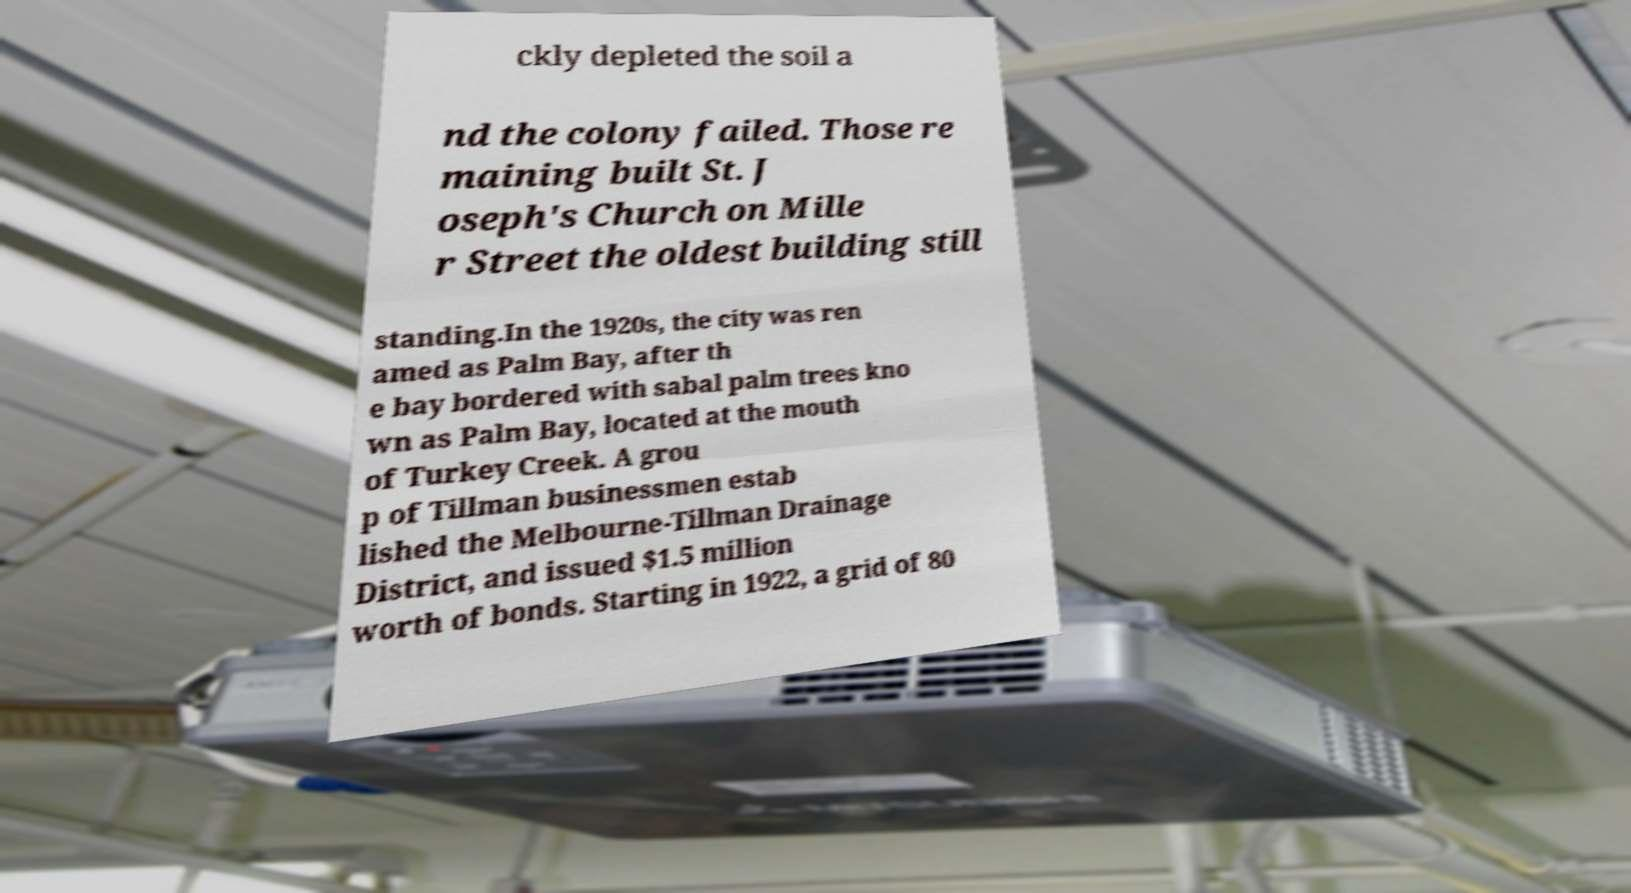Could you assist in decoding the text presented in this image and type it out clearly? ckly depleted the soil a nd the colony failed. Those re maining built St. J oseph's Church on Mille r Street the oldest building still standing.In the 1920s, the city was ren amed as Palm Bay, after th e bay bordered with sabal palm trees kno wn as Palm Bay, located at the mouth of Turkey Creek. A grou p of Tillman businessmen estab lished the Melbourne-Tillman Drainage District, and issued $1.5 million worth of bonds. Starting in 1922, a grid of 80 